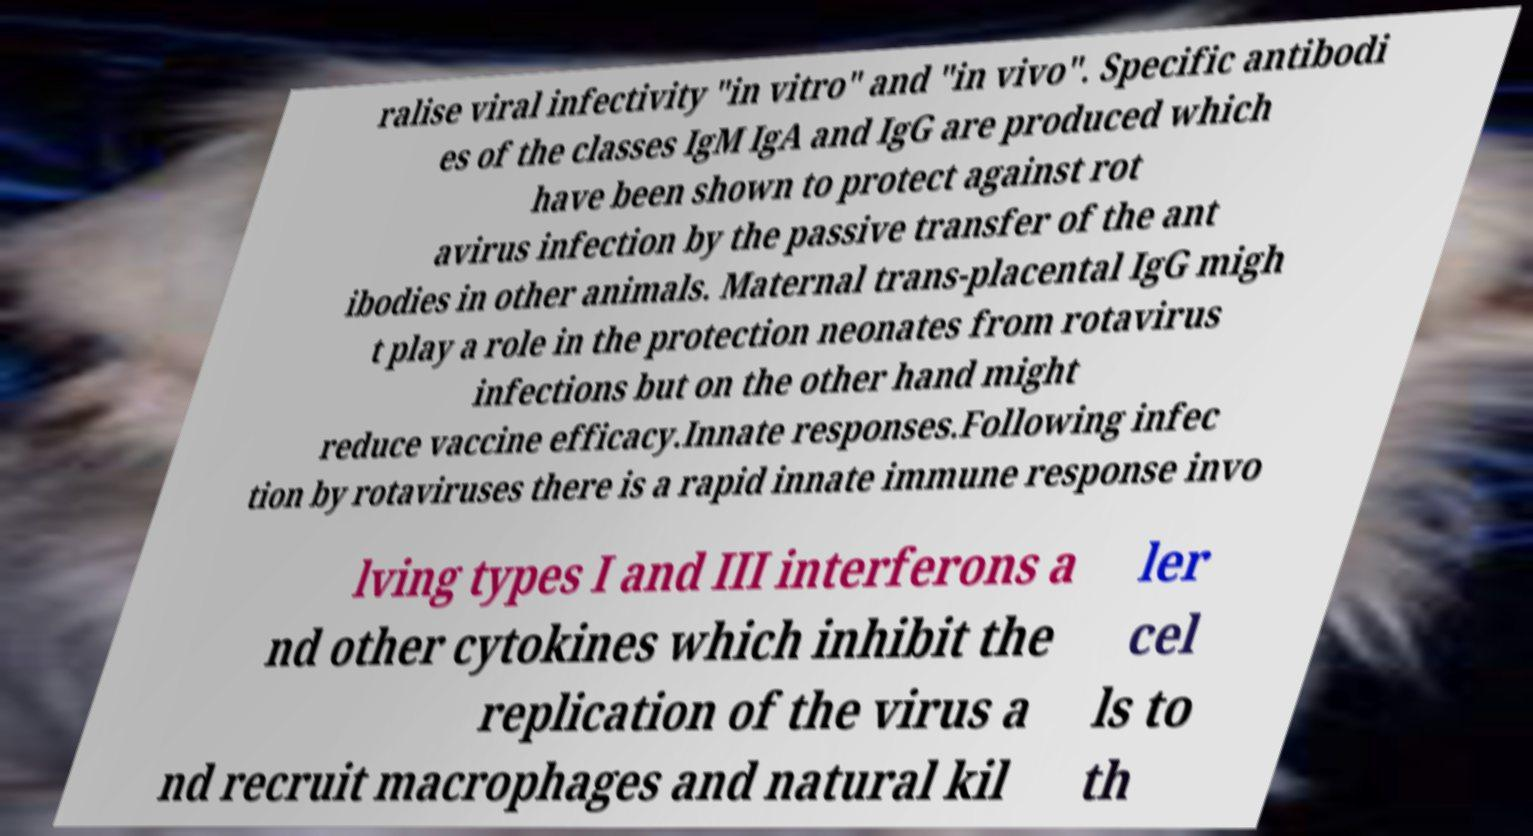Could you assist in decoding the text presented in this image and type it out clearly? ralise viral infectivity "in vitro" and "in vivo". Specific antibodi es of the classes IgM IgA and IgG are produced which have been shown to protect against rot avirus infection by the passive transfer of the ant ibodies in other animals. Maternal trans-placental IgG migh t play a role in the protection neonates from rotavirus infections but on the other hand might reduce vaccine efficacy.Innate responses.Following infec tion by rotaviruses there is a rapid innate immune response invo lving types I and III interferons a nd other cytokines which inhibit the replication of the virus a nd recruit macrophages and natural kil ler cel ls to th 